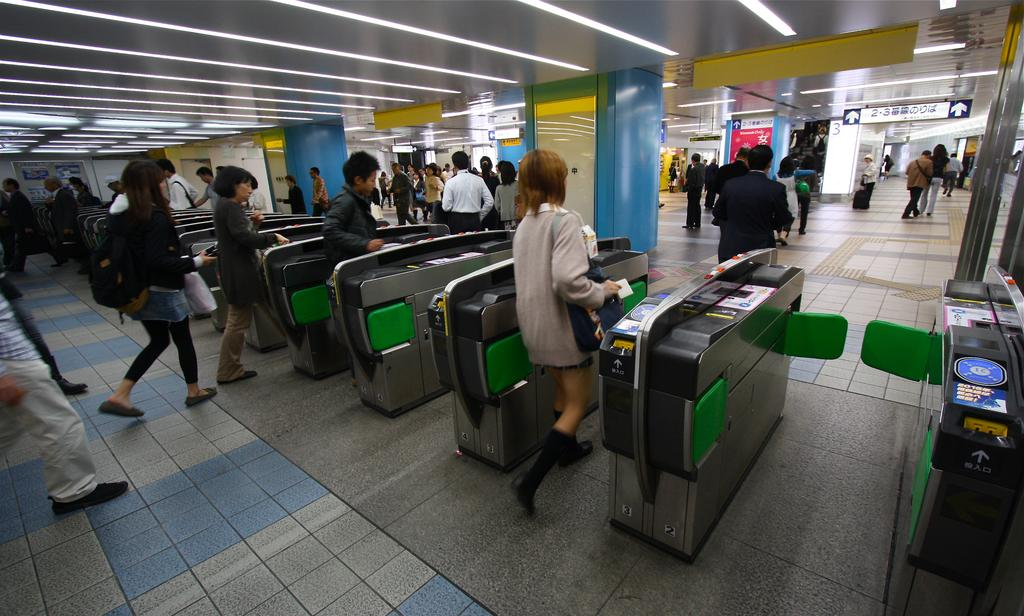What are the people in the image doing? The persons standing on the floor in the image are likely waiting or standing near the automatic entry gates. What type of gates are present in the image? Automatic entry gates are present in the image. What type of information can be found on the visible signs in the image? Sign boards and name boards are visible in the image, which may provide information or directions. What type of establishments can be seen in the image? Stores are present in the image. Can you hear the bells ringing in the image? There are no bells present in the image, so it is not possible to hear them ringing. 